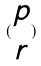Convert formula to latex. <formula><loc_0><loc_0><loc_500><loc_500>( \begin{matrix} p \\ r \end{matrix} )</formula> 